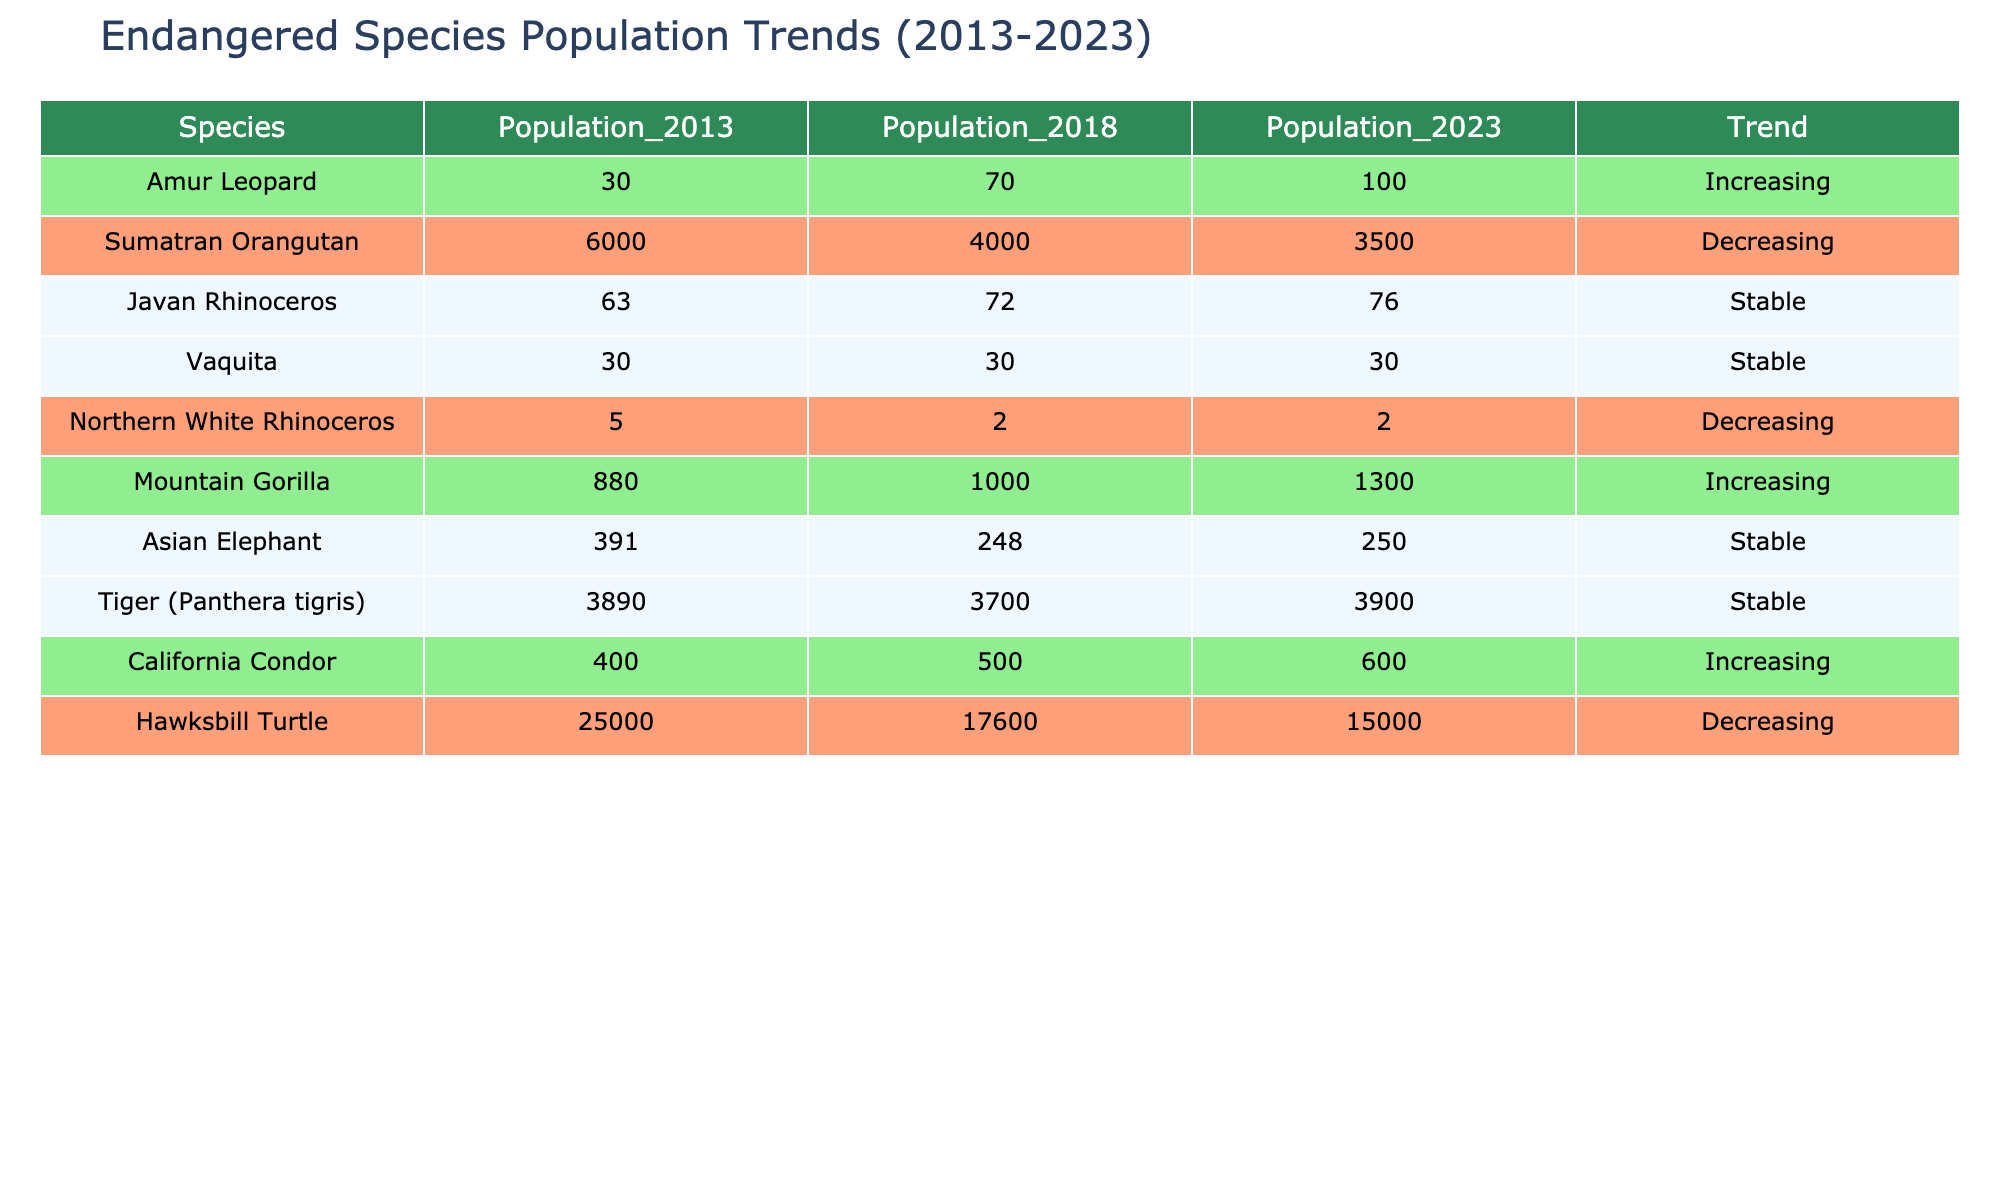What is the population of the Amur Leopard in 2023? The table shows the population of the Amur Leopard in the year 2023 as listed under the Population_2023 column. From the table, the value is 100.
Answer: 100 How many species have an increasing population trend? To determine the number of species with an increasing trend, we look at the Trend column and count entries marked as 'Increasing'. The species with this trend are Amur Leopard, Mountain Gorilla, and California Condor, totaling 3 species.
Answer: 3 What is the population change of the Sumatran Orangutan from 2013 to 2023? We find the population of the Sumatran Orangutan in both 2013 and 2023 from the respective columns. The population was 6000 in 2013 and dropped to 3500 in 2023. The change can be calculated as 3500 - 6000, which equals -2500.
Answer: -2500 Is the population of the Vaquita stable, according to the table? In the Trend column, we check the Vaquita's entry. It states 'Stable', indicating that its population has not changed significantly over the years listed. Thus, the answer is yes.
Answer: Yes What was the population of the Northern White Rhinoceros in 2013 compared to 2023? We need to look at the corresponding populations from both years. In 2013, the Northern White Rhinoceros had a population of 5, and in 2023, it remained the same at 2. The decrease in population from 5 to 2 shows a significant decline.
Answer: 5 in 2013, 2 in 2023 How many species have a stable population trend? We examine the Trend column and count the entries marked as 'Stable'. The species with a stable trend are Javan Rhinoceros, Vaquita, Asian Elephant, and Tiger, totaling 4 species.
Answer: 4 Which species showed the most significant decline in population from 2013 to 2023? We analyze the populations of each species to find the decline over the ten years. The Sumatran Orangutan decreased from 6000 to 3500, a change of 2500, which is the largest decline among the listed species.
Answer: Sumatran Orangutan What is the average population of all species in 2018? We add up the populations for all species in 2018: 70 + 4000 + 72 + 30 + 2 + 1000 + 248 + 3700 + 500 + 17600 = 20152. Then, we divide by the number of species, which is 10. The average therefore is 20152 / 10 = 2015.2.
Answer: 2015.2 How many species are listed with a decreasing trend? To find this, we look at the Trend column and count the entries that are marked 'Decreasing'. The species with this trend are Sumatran Orangutan, Northern White Rhinoceros, and Hawksbill Turtle, giving us a total of 3.
Answer: 3 